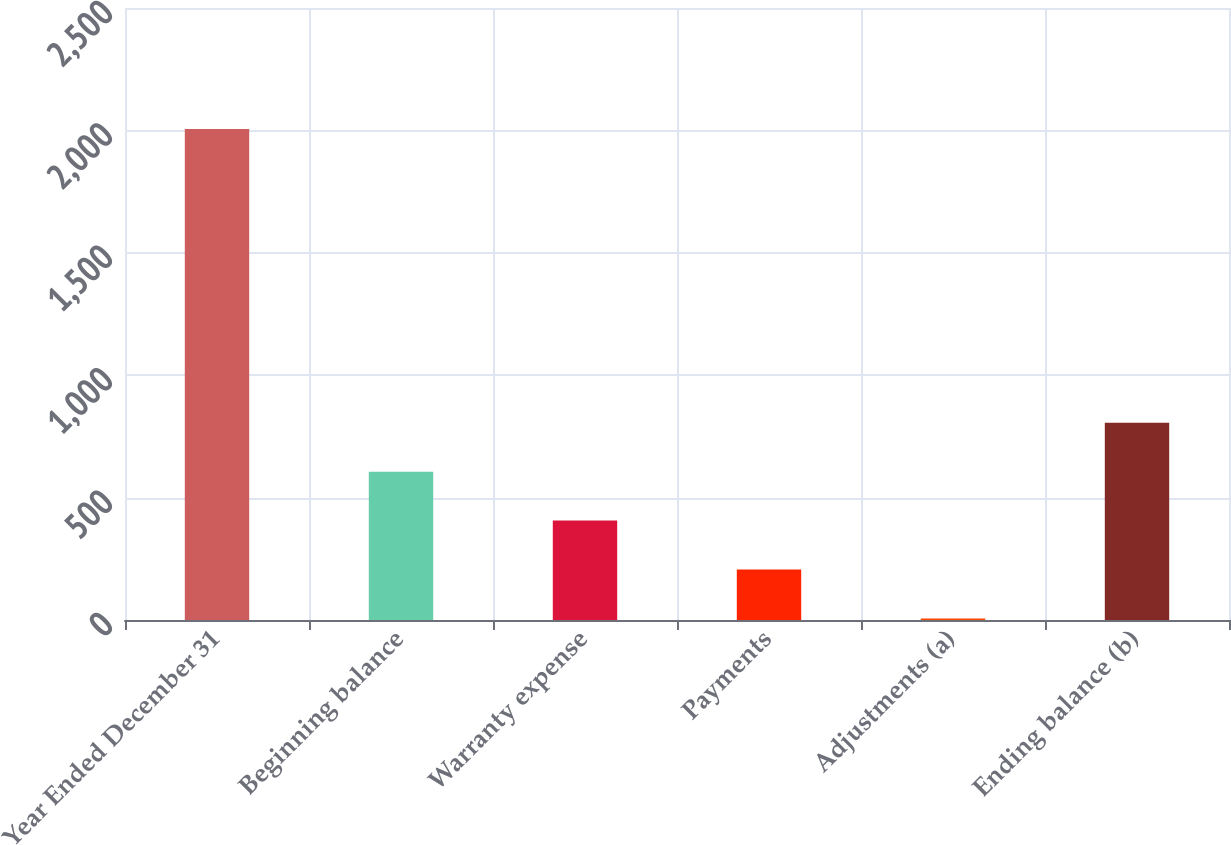<chart> <loc_0><loc_0><loc_500><loc_500><bar_chart><fcel>Year Ended December 31<fcel>Beginning balance<fcel>Warranty expense<fcel>Payments<fcel>Adjustments (a)<fcel>Ending balance (b)<nl><fcel>2006<fcel>606<fcel>406<fcel>206<fcel>6<fcel>806<nl></chart> 